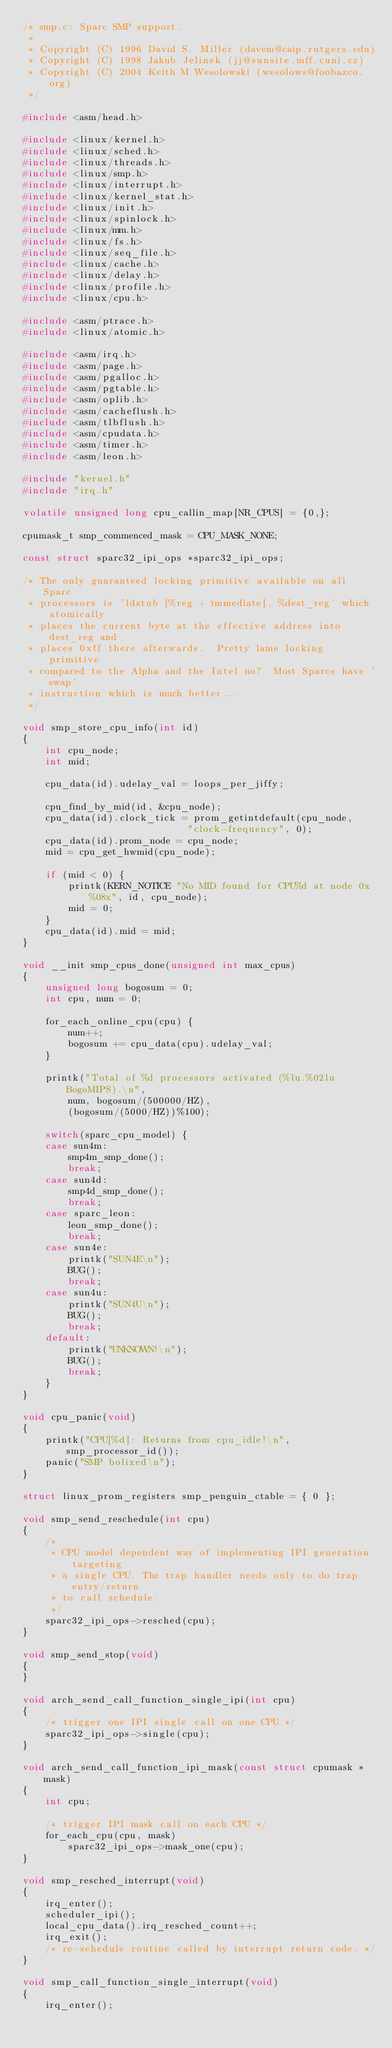<code> <loc_0><loc_0><loc_500><loc_500><_C_>/* smp.c: Sparc SMP support.
 *
 * Copyright (C) 1996 David S. Miller (davem@caip.rutgers.edu)
 * Copyright (C) 1998 Jakub Jelinek (jj@sunsite.mff.cuni.cz)
 * Copyright (C) 2004 Keith M Wesolowski (wesolows@foobazco.org)
 */

#include <asm/head.h>

#include <linux/kernel.h>
#include <linux/sched.h>
#include <linux/threads.h>
#include <linux/smp.h>
#include <linux/interrupt.h>
#include <linux/kernel_stat.h>
#include <linux/init.h>
#include <linux/spinlock.h>
#include <linux/mm.h>
#include <linux/fs.h>
#include <linux/seq_file.h>
#include <linux/cache.h>
#include <linux/delay.h>
#include <linux/profile.h>
#include <linux/cpu.h>

#include <asm/ptrace.h>
#include <linux/atomic.h>

#include <asm/irq.h>
#include <asm/page.h>
#include <asm/pgalloc.h>
#include <asm/pgtable.h>
#include <asm/oplib.h>
#include <asm/cacheflush.h>
#include <asm/tlbflush.h>
#include <asm/cpudata.h>
#include <asm/timer.h>
#include <asm/leon.h>

#include "kernel.h"
#include "irq.h"

volatile unsigned long cpu_callin_map[NR_CPUS] = {0,};

cpumask_t smp_commenced_mask = CPU_MASK_NONE;

const struct sparc32_ipi_ops *sparc32_ipi_ops;

/* The only guaranteed locking primitive available on all Sparc
 * processors is 'ldstub [%reg + immediate], %dest_reg' which atomically
 * places the current byte at the effective address into dest_reg and
 * places 0xff there afterwards.  Pretty lame locking primitive
 * compared to the Alpha and the Intel no?  Most Sparcs have 'swap'
 * instruction which is much better...
 */

void smp_store_cpu_info(int id)
{
	int cpu_node;
	int mid;

	cpu_data(id).udelay_val = loops_per_jiffy;

	cpu_find_by_mid(id, &cpu_node);
	cpu_data(id).clock_tick = prom_getintdefault(cpu_node,
						     "clock-frequency", 0);
	cpu_data(id).prom_node = cpu_node;
	mid = cpu_get_hwmid(cpu_node);

	if (mid < 0) {
		printk(KERN_NOTICE "No MID found for CPU%d at node 0x%08x", id, cpu_node);
		mid = 0;
	}
	cpu_data(id).mid = mid;
}

void __init smp_cpus_done(unsigned int max_cpus)
{
	unsigned long bogosum = 0;
	int cpu, num = 0;

	for_each_online_cpu(cpu) {
		num++;
		bogosum += cpu_data(cpu).udelay_val;
	}

	printk("Total of %d processors activated (%lu.%02lu BogoMIPS).\n",
		num, bogosum/(500000/HZ),
		(bogosum/(5000/HZ))%100);

	switch(sparc_cpu_model) {
	case sun4m:
		smp4m_smp_done();
		break;
	case sun4d:
		smp4d_smp_done();
		break;
	case sparc_leon:
		leon_smp_done();
		break;
	case sun4e:
		printk("SUN4E\n");
		BUG();
		break;
	case sun4u:
		printk("SUN4U\n");
		BUG();
		break;
	default:
		printk("UNKNOWN!\n");
		BUG();
		break;
	}
}

void cpu_panic(void)
{
	printk("CPU[%d]: Returns from cpu_idle!\n", smp_processor_id());
	panic("SMP bolixed\n");
}

struct linux_prom_registers smp_penguin_ctable = { 0 };

void smp_send_reschedule(int cpu)
{
	/*
	 * CPU model dependent way of implementing IPI generation targeting
	 * a single CPU. The trap handler needs only to do trap entry/return
	 * to call schedule.
	 */
	sparc32_ipi_ops->resched(cpu);
}

void smp_send_stop(void)
{
}

void arch_send_call_function_single_ipi(int cpu)
{
	/* trigger one IPI single call on one CPU */
	sparc32_ipi_ops->single(cpu);
}

void arch_send_call_function_ipi_mask(const struct cpumask *mask)
{
	int cpu;

	/* trigger IPI mask call on each CPU */
	for_each_cpu(cpu, mask)
		sparc32_ipi_ops->mask_one(cpu);
}

void smp_resched_interrupt(void)
{
	irq_enter();
	scheduler_ipi();
	local_cpu_data().irq_resched_count++;
	irq_exit();
	/* re-schedule routine called by interrupt return code. */
}

void smp_call_function_single_interrupt(void)
{
	irq_enter();</code> 